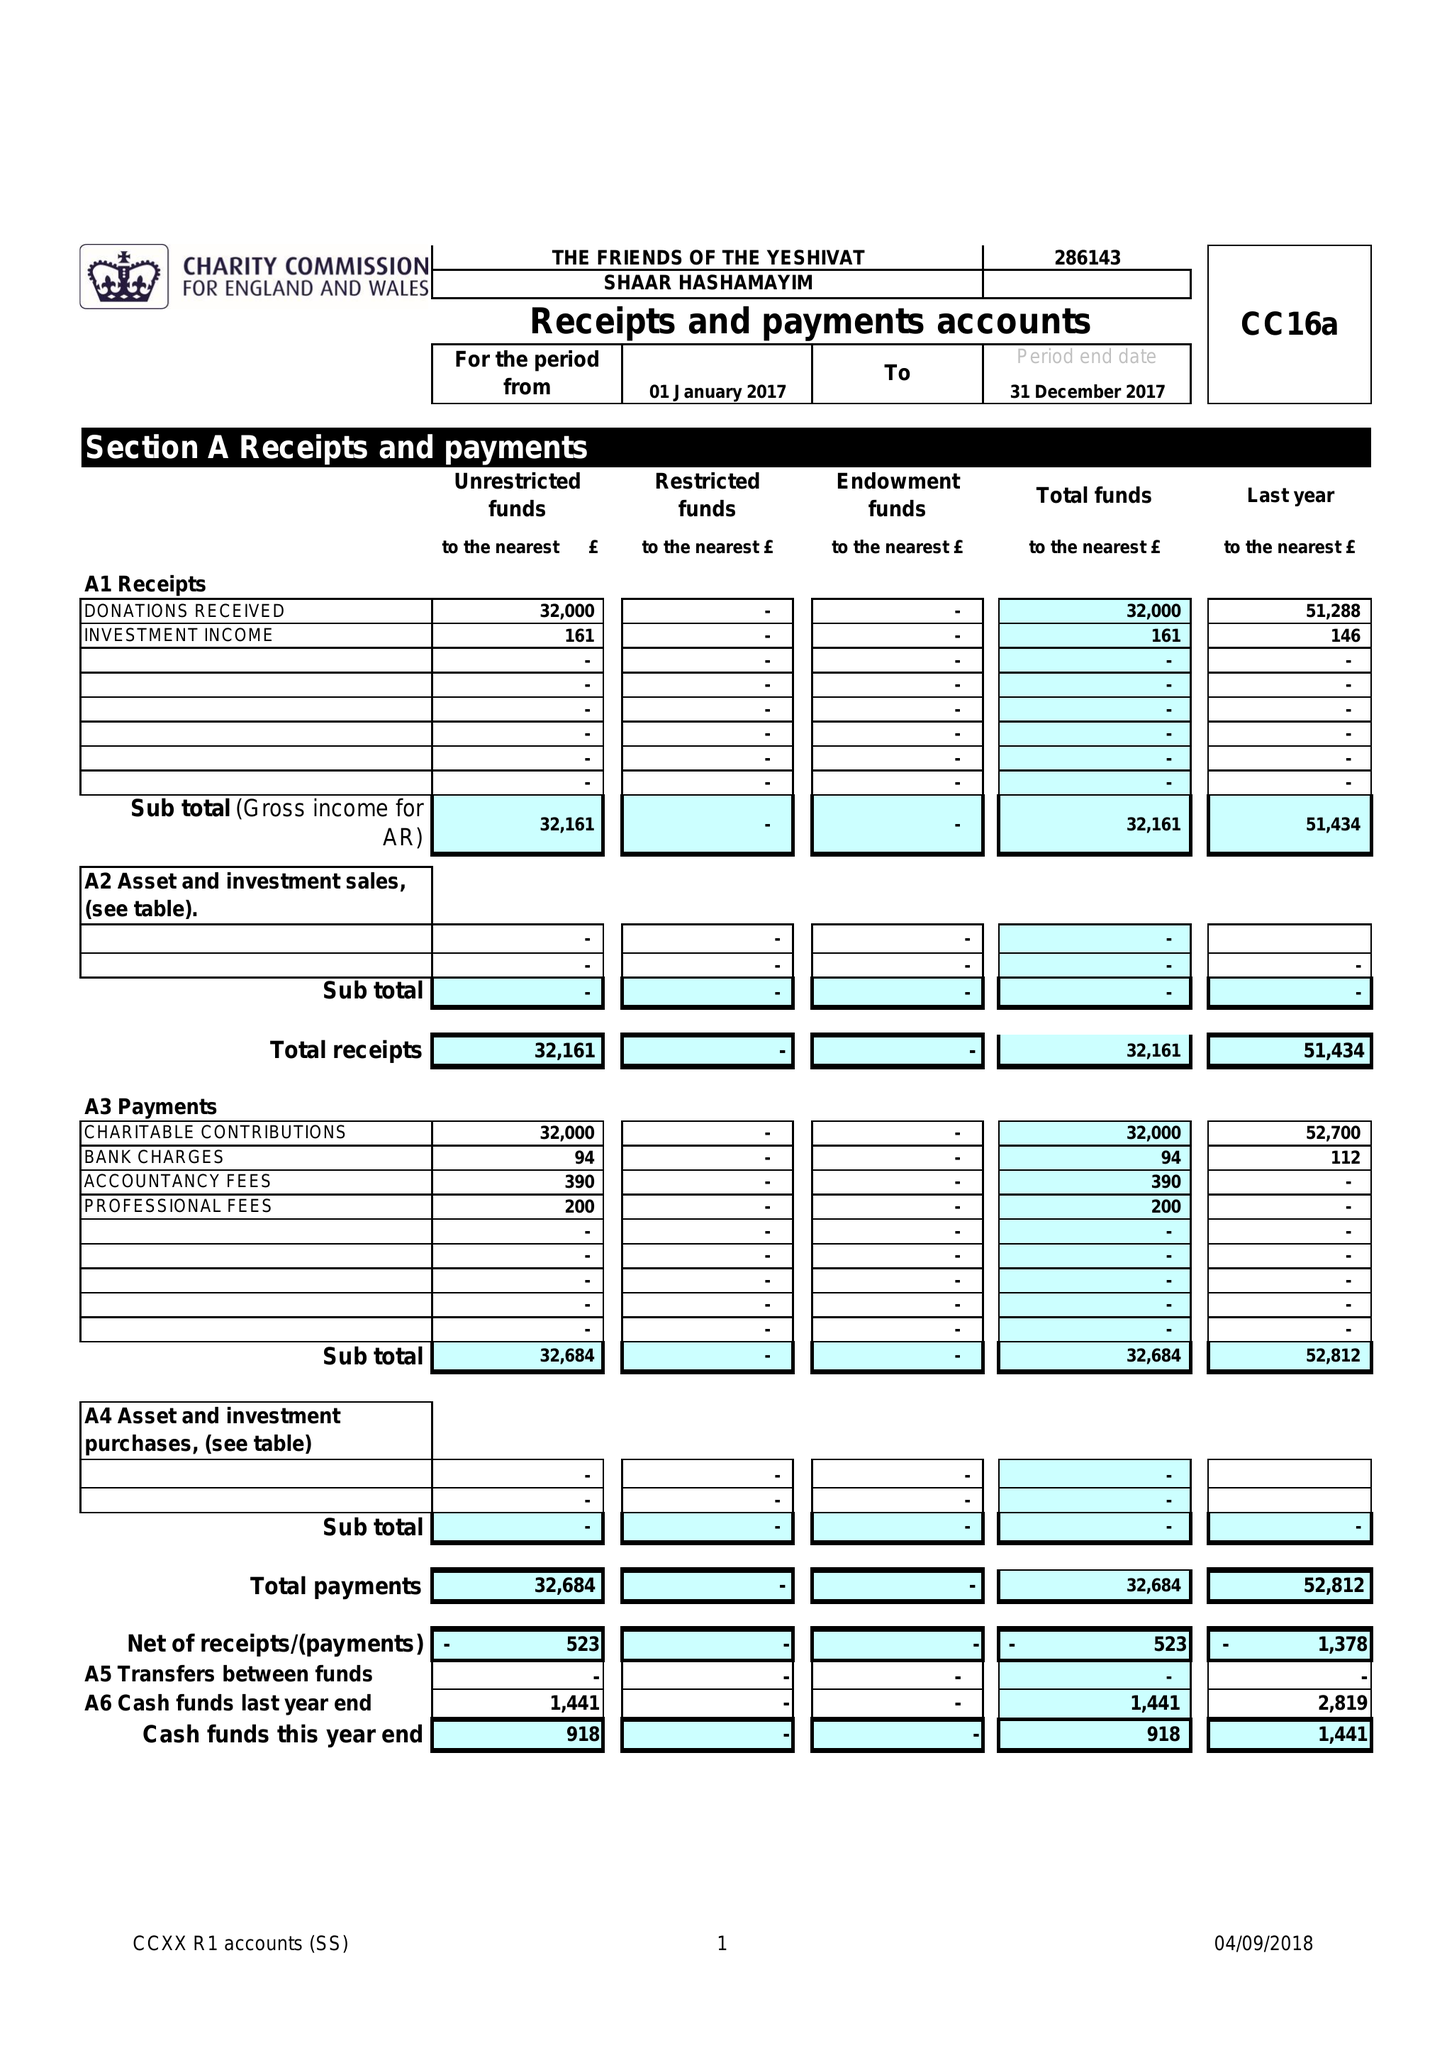What is the value for the spending_annually_in_british_pounds?
Answer the question using a single word or phrase. 32684.00 